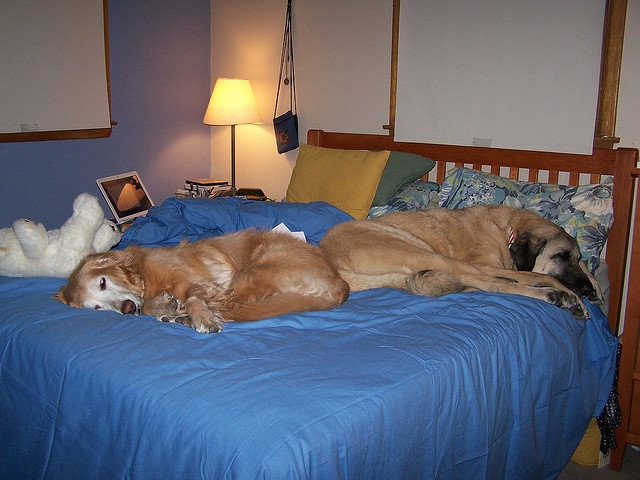Describe the objects in this image and their specific colors. I can see bed in gray, blue, darkblue, and navy tones, dog in gray, tan, and black tones, dog in gray, brown, and tan tones, teddy bear in gray, darkgray, and lightgray tones, and handbag in gray, black, tan, and maroon tones in this image. 